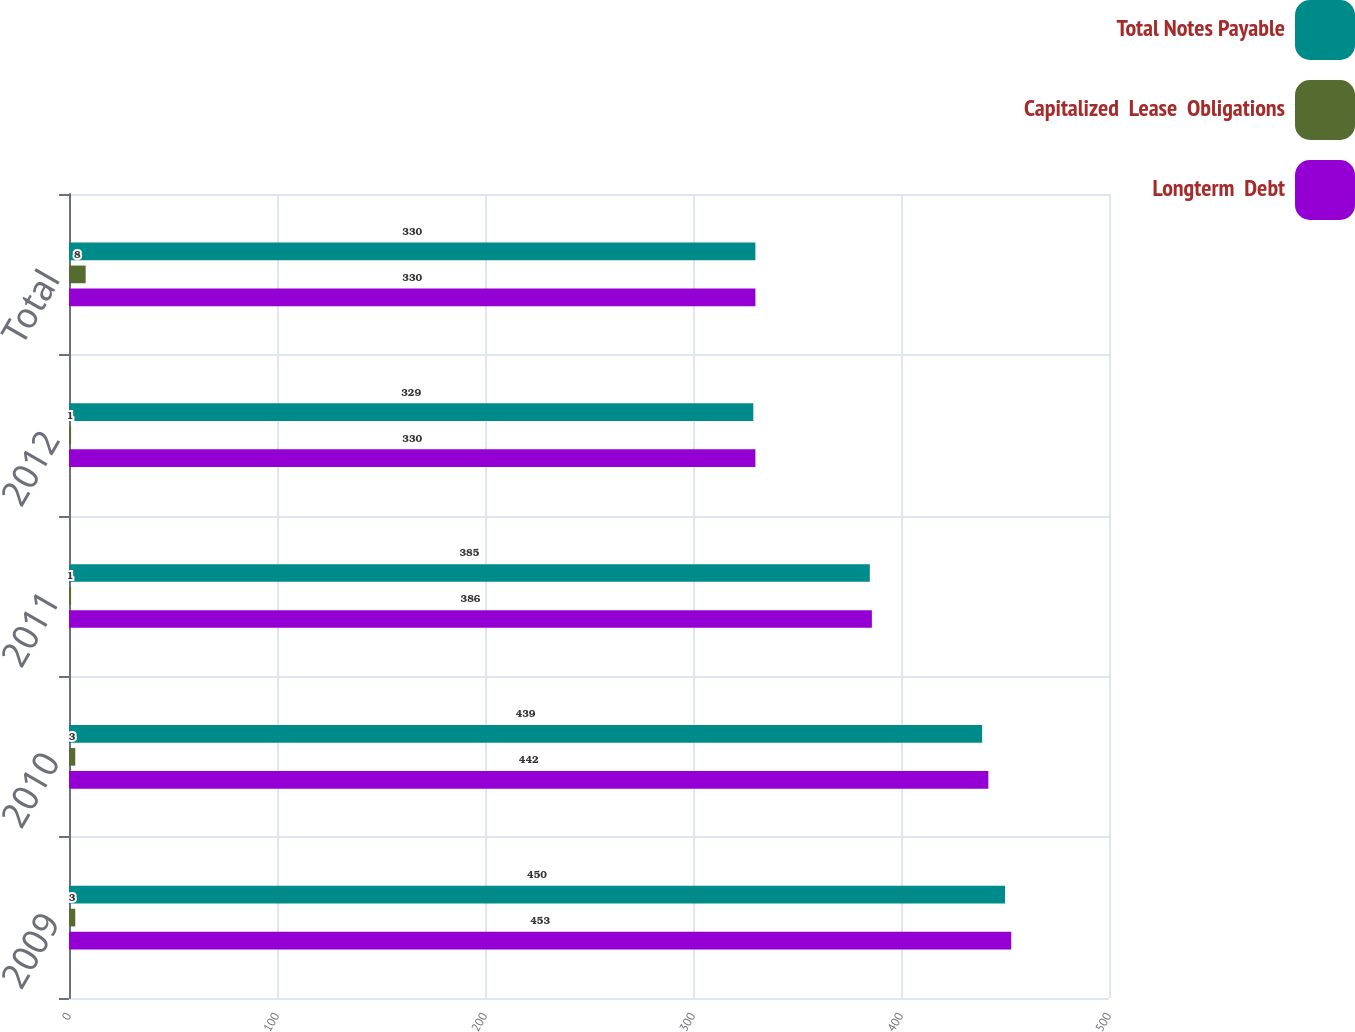<chart> <loc_0><loc_0><loc_500><loc_500><stacked_bar_chart><ecel><fcel>2009<fcel>2010<fcel>2011<fcel>2012<fcel>Total<nl><fcel>Total Notes Payable<fcel>450<fcel>439<fcel>385<fcel>329<fcel>330<nl><fcel>Capitalized  Lease  Obligations<fcel>3<fcel>3<fcel>1<fcel>1<fcel>8<nl><fcel>Longterm  Debt<fcel>453<fcel>442<fcel>386<fcel>330<fcel>330<nl></chart> 